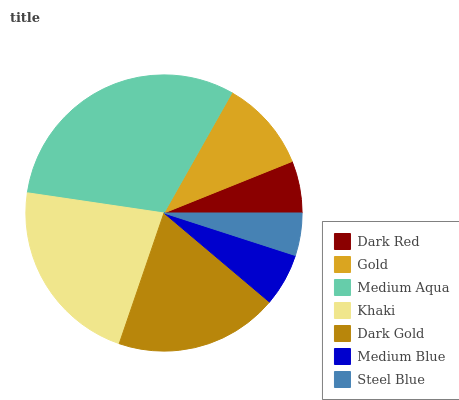Is Steel Blue the minimum?
Answer yes or no. Yes. Is Medium Aqua the maximum?
Answer yes or no. Yes. Is Gold the minimum?
Answer yes or no. No. Is Gold the maximum?
Answer yes or no. No. Is Gold greater than Dark Red?
Answer yes or no. Yes. Is Dark Red less than Gold?
Answer yes or no. Yes. Is Dark Red greater than Gold?
Answer yes or no. No. Is Gold less than Dark Red?
Answer yes or no. No. Is Gold the high median?
Answer yes or no. Yes. Is Gold the low median?
Answer yes or no. Yes. Is Steel Blue the high median?
Answer yes or no. No. Is Khaki the low median?
Answer yes or no. No. 